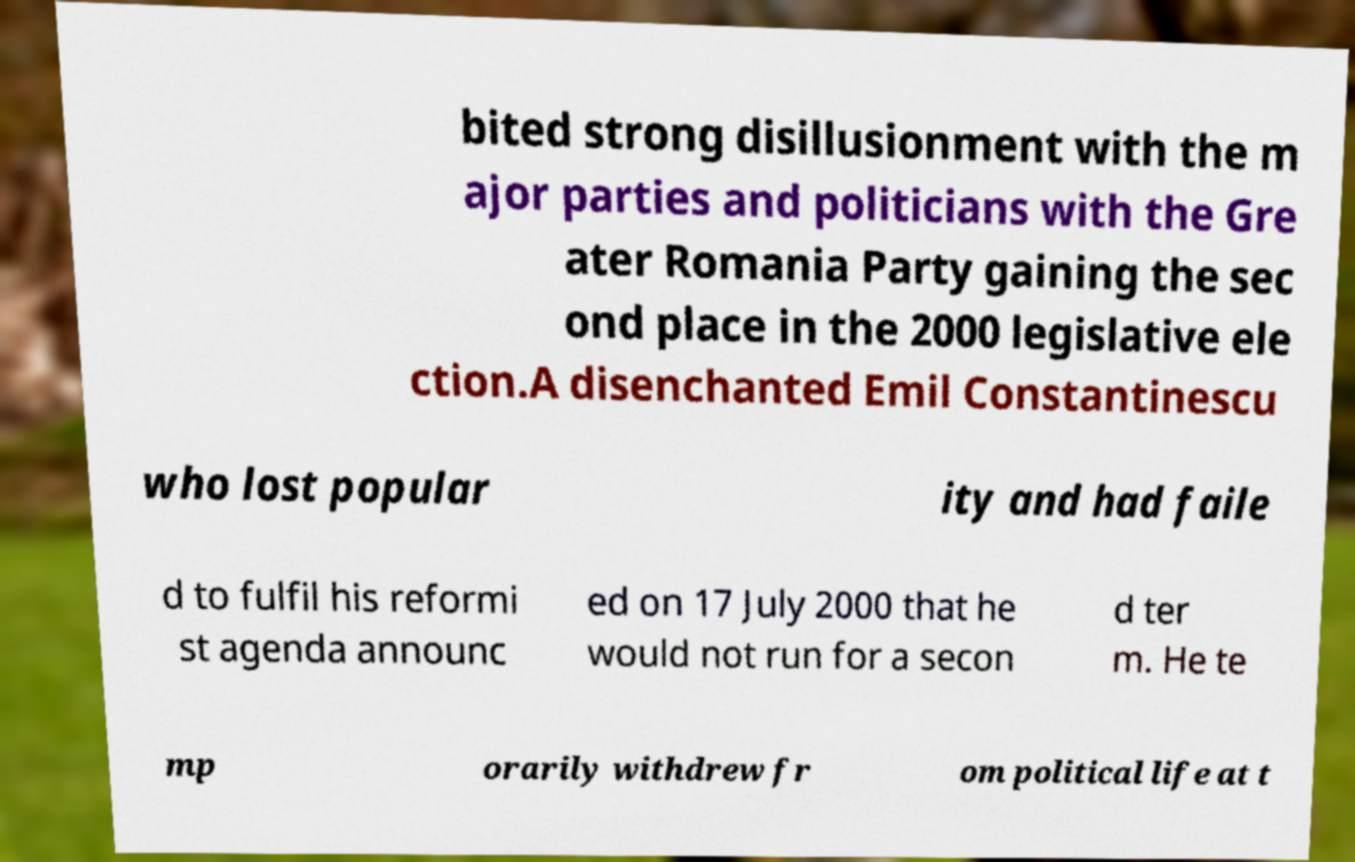Please identify and transcribe the text found in this image. bited strong disillusionment with the m ajor parties and politicians with the Gre ater Romania Party gaining the sec ond place in the 2000 legislative ele ction.A disenchanted Emil Constantinescu who lost popular ity and had faile d to fulfil his reformi st agenda announc ed on 17 July 2000 that he would not run for a secon d ter m. He te mp orarily withdrew fr om political life at t 